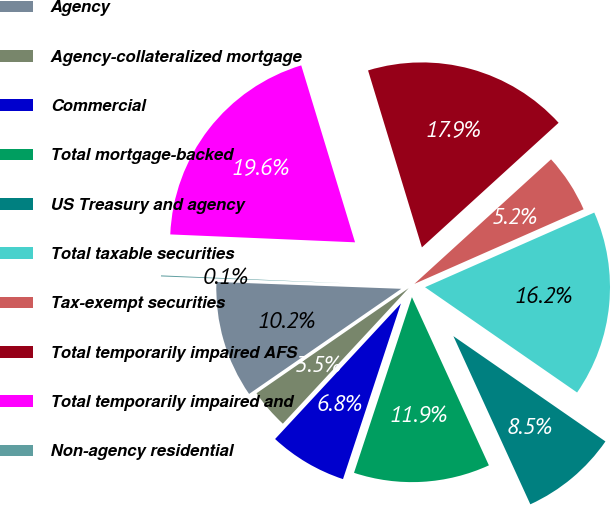Convert chart. <chart><loc_0><loc_0><loc_500><loc_500><pie_chart><fcel>Agency<fcel>Agency-collateralized mortgage<fcel>Commercial<fcel>Total mortgage-backed<fcel>US Treasury and agency<fcel>Total taxable securities<fcel>Tax-exempt securities<fcel>Total temporarily impaired AFS<fcel>Total temporarily impaired and<fcel>Non-agency residential<nl><fcel>10.21%<fcel>3.47%<fcel>6.84%<fcel>11.9%<fcel>8.53%<fcel>16.25%<fcel>5.15%<fcel>17.94%<fcel>19.62%<fcel>0.09%<nl></chart> 